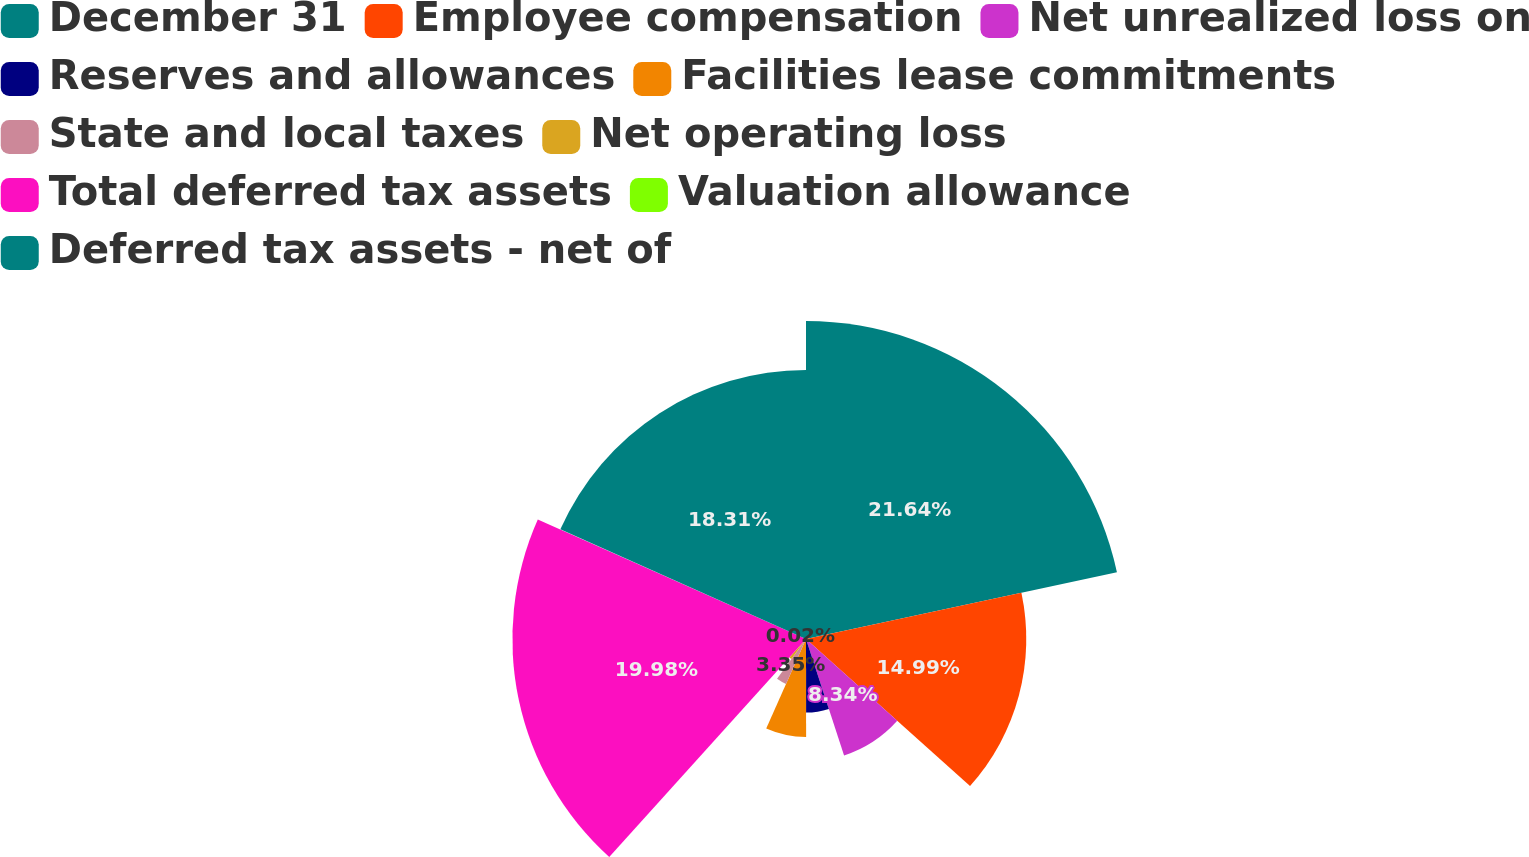Convert chart to OTSL. <chart><loc_0><loc_0><loc_500><loc_500><pie_chart><fcel>December 31<fcel>Employee compensation<fcel>Net unrealized loss on<fcel>Reserves and allowances<fcel>Facilities lease commitments<fcel>State and local taxes<fcel>Net operating loss<fcel>Total deferred tax assets<fcel>Valuation allowance<fcel>Deferred tax assets - net of<nl><fcel>21.64%<fcel>14.99%<fcel>8.34%<fcel>5.01%<fcel>6.67%<fcel>3.35%<fcel>1.69%<fcel>19.98%<fcel>0.02%<fcel>18.31%<nl></chart> 